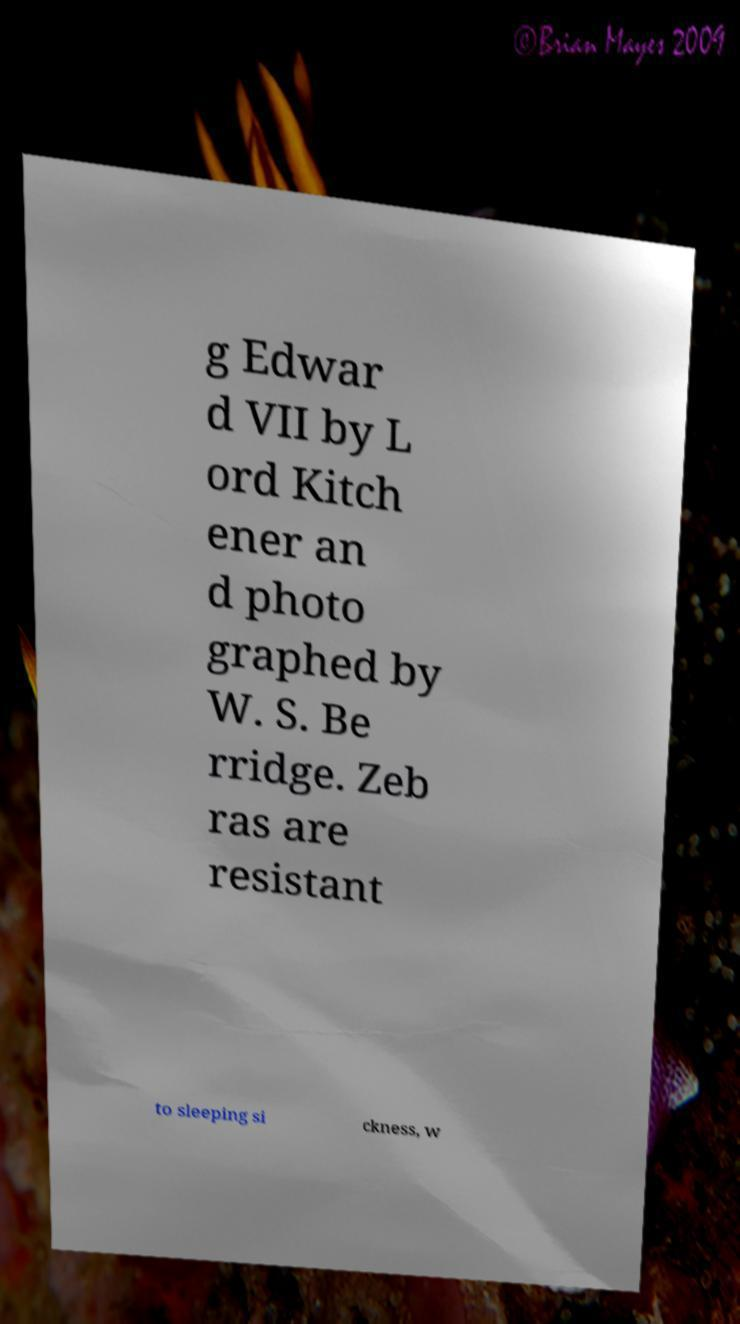Could you extract and type out the text from this image? g Edwar d VII by L ord Kitch ener an d photo graphed by W. S. Be rridge. Zeb ras are resistant to sleeping si ckness, w 